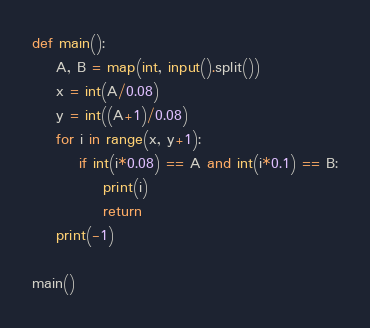Convert code to text. <code><loc_0><loc_0><loc_500><loc_500><_Python_>def main():
    A, B = map(int, input().split())
    x = int(A/0.08)
    y = int((A+1)/0.08)
    for i in range(x, y+1):
        if int(i*0.08) == A and int(i*0.1) == B:
            print(i)
            return
    print(-1)

main()</code> 